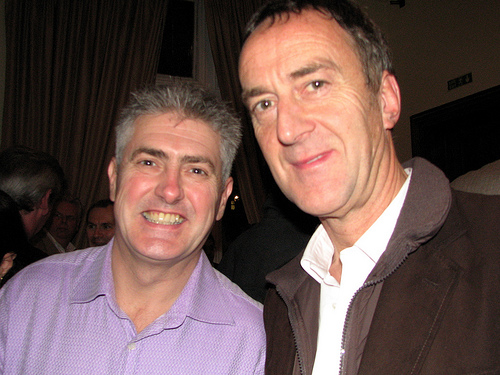<image>
Is there a man to the right of the shirt? No. The man is not to the right of the shirt. The horizontal positioning shows a different relationship. 